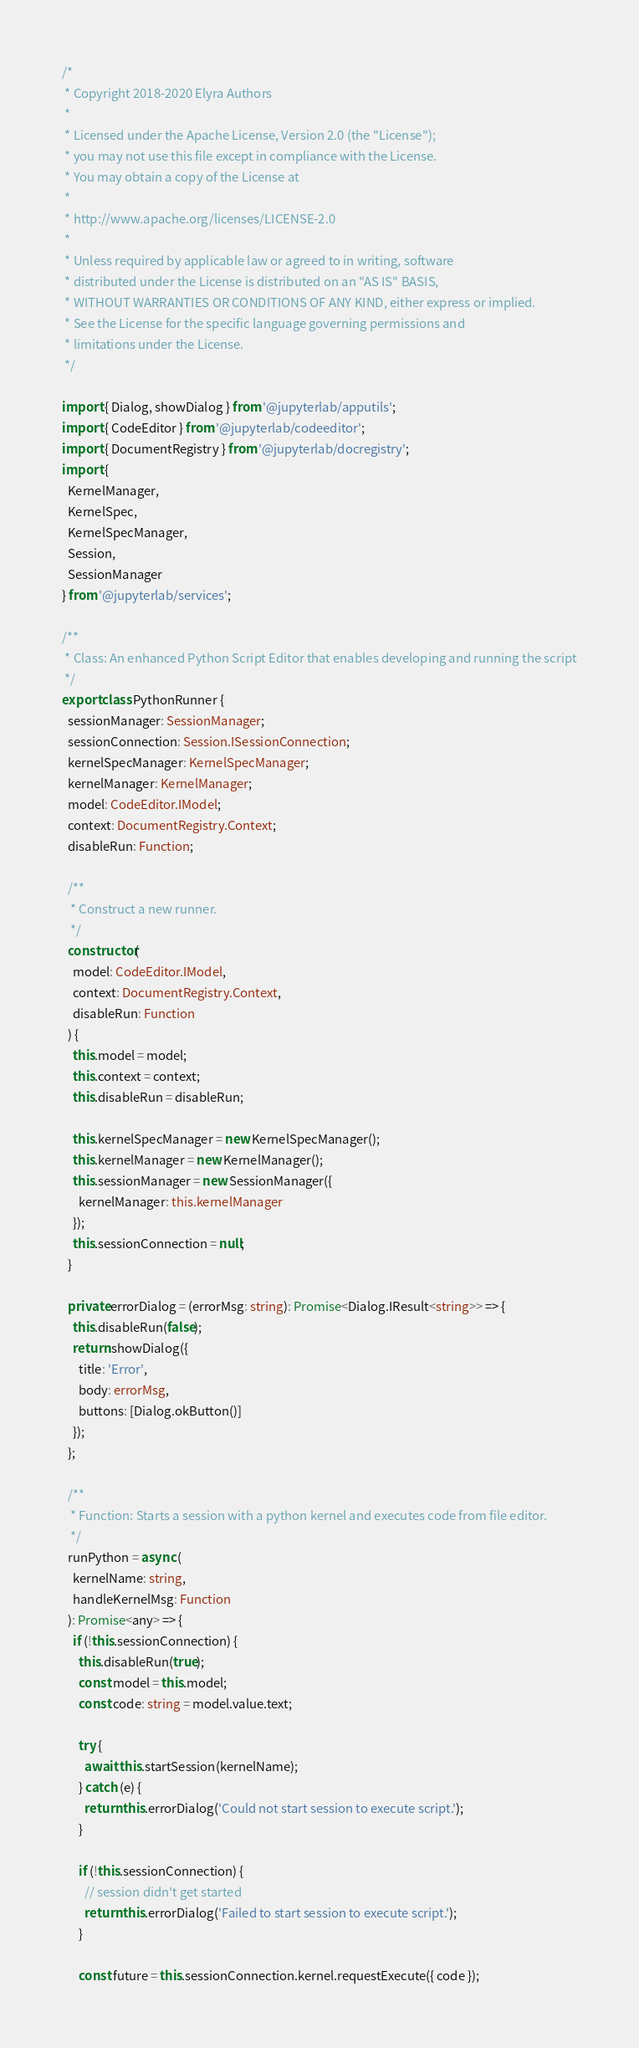Convert code to text. <code><loc_0><loc_0><loc_500><loc_500><_TypeScript_>/*
 * Copyright 2018-2020 Elyra Authors
 *
 * Licensed under the Apache License, Version 2.0 (the "License");
 * you may not use this file except in compliance with the License.
 * You may obtain a copy of the License at
 *
 * http://www.apache.org/licenses/LICENSE-2.0
 *
 * Unless required by applicable law or agreed to in writing, software
 * distributed under the License is distributed on an "AS IS" BASIS,
 * WITHOUT WARRANTIES OR CONDITIONS OF ANY KIND, either express or implied.
 * See the License for the specific language governing permissions and
 * limitations under the License.
 */

import { Dialog, showDialog } from '@jupyterlab/apputils';
import { CodeEditor } from '@jupyterlab/codeeditor';
import { DocumentRegistry } from '@jupyterlab/docregistry';
import {
  KernelManager,
  KernelSpec,
  KernelSpecManager,
  Session,
  SessionManager
} from '@jupyterlab/services';

/**
 * Class: An enhanced Python Script Editor that enables developing and running the script
 */
export class PythonRunner {
  sessionManager: SessionManager;
  sessionConnection: Session.ISessionConnection;
  kernelSpecManager: KernelSpecManager;
  kernelManager: KernelManager;
  model: CodeEditor.IModel;
  context: DocumentRegistry.Context;
  disableRun: Function;

  /**
   * Construct a new runner.
   */
  constructor(
    model: CodeEditor.IModel,
    context: DocumentRegistry.Context,
    disableRun: Function
  ) {
    this.model = model;
    this.context = context;
    this.disableRun = disableRun;

    this.kernelSpecManager = new KernelSpecManager();
    this.kernelManager = new KernelManager();
    this.sessionManager = new SessionManager({
      kernelManager: this.kernelManager
    });
    this.sessionConnection = null;
  }

  private errorDialog = (errorMsg: string): Promise<Dialog.IResult<string>> => {
    this.disableRun(false);
    return showDialog({
      title: 'Error',
      body: errorMsg,
      buttons: [Dialog.okButton()]
    });
  };

  /**
   * Function: Starts a session with a python kernel and executes code from file editor.
   */
  runPython = async (
    kernelName: string,
    handleKernelMsg: Function
  ): Promise<any> => {
    if (!this.sessionConnection) {
      this.disableRun(true);
      const model = this.model;
      const code: string = model.value.text;

      try {
        await this.startSession(kernelName);
      } catch (e) {
        return this.errorDialog('Could not start session to execute script.');
      }

      if (!this.sessionConnection) {
        // session didn't get started
        return this.errorDialog('Failed to start session to execute script.');
      }

      const future = this.sessionConnection.kernel.requestExecute({ code });
</code> 